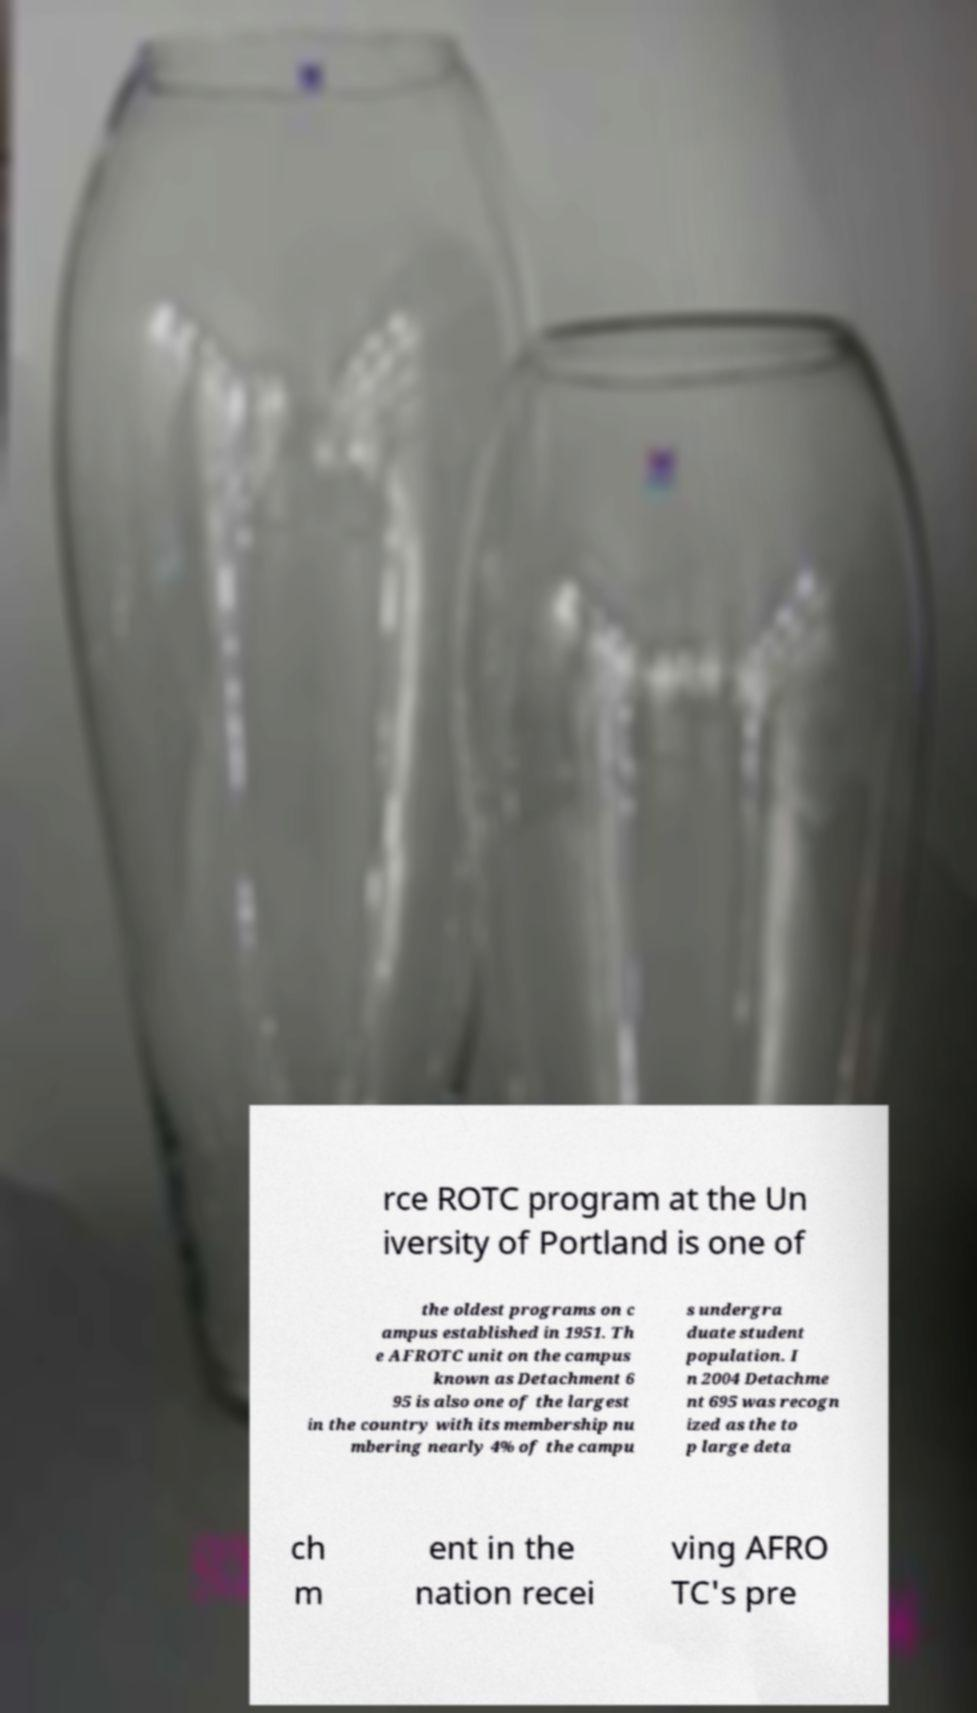There's text embedded in this image that I need extracted. Can you transcribe it verbatim? rce ROTC program at the Un iversity of Portland is one of the oldest programs on c ampus established in 1951. Th e AFROTC unit on the campus known as Detachment 6 95 is also one of the largest in the country with its membership nu mbering nearly 4% of the campu s undergra duate student population. I n 2004 Detachme nt 695 was recogn ized as the to p large deta ch m ent in the nation recei ving AFRO TC's pre 